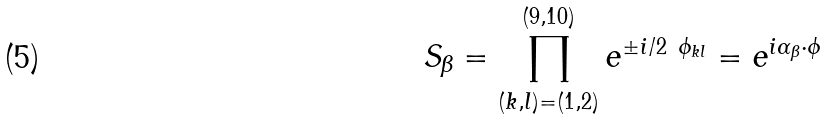<formula> <loc_0><loc_0><loc_500><loc_500>S _ { \beta } = \prod _ { ( k , l ) = ( 1 , 2 ) } ^ { ( 9 , 1 0 ) } e ^ { \pm i / 2 \ \phi _ { k l } } = e ^ { i \alpha _ { \beta } \cdot \phi }</formula> 